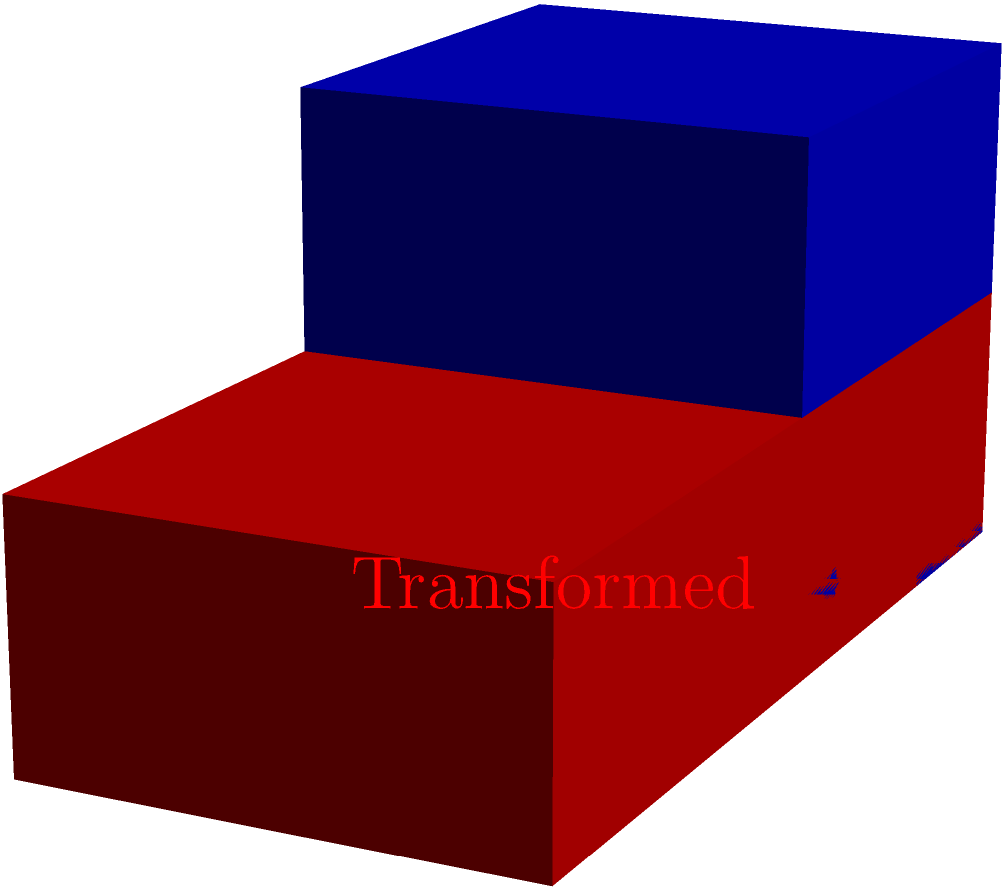Consider a linear transformation $T$ that maps a unit cube to a rectangular cuboid. If $T$ doubles the length along the x-axis, leaves the y-axis unchanged, and halves the length along the z-axis, what is the volume of the transformed cuboid in terms of the original cube's volume? To solve this problem, let's follow these steps:

1) Recall that for a linear transformation, the volume scaling factor is equal to the determinant of the transformation matrix.

2) The transformation $T$ can be represented by the matrix:
   $$T = \begin{pmatrix}
   2 & 0 & 0 \\
   0 & 1 & 0 \\
   0 & 0 & 0.5
   \end{pmatrix}$$

3) The determinant of this matrix is:
   $$\det(T) = 2 \cdot 1 \cdot 0.5 = 1$$

4) This means that the volume of the transformed cuboid is equal to the volume of the original cube.

5) However, we can also verify this geometrically:
   - The length along x-axis is doubled: factor of 2
   - The length along y-axis is unchanged: factor of 1
   - The length along z-axis is halved: factor of 0.5

6) The volume scaling is the product of these factors:
   $$2 \cdot 1 \cdot 0.5 = 1$$

Therefore, the volume of the transformed cuboid is equal to the volume of the original cube.
Answer: 1 times the original volume 